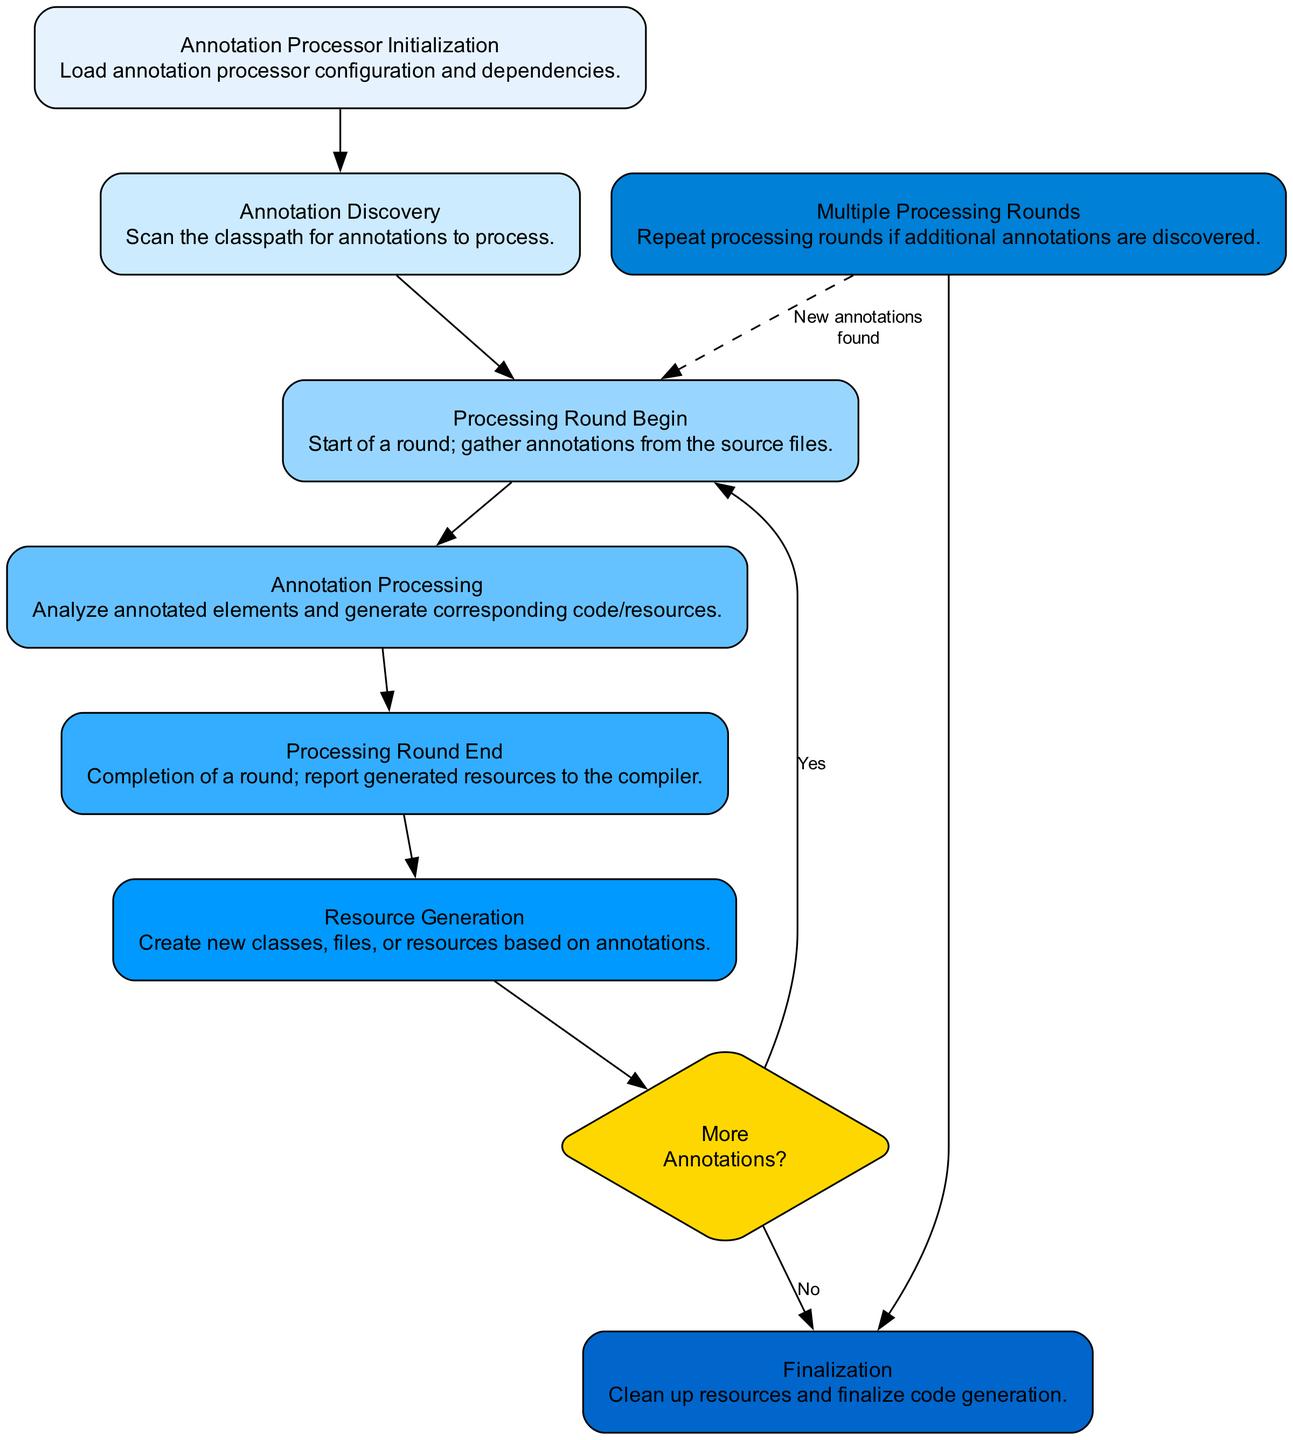What is the first step in the lifecycle? The first step listed in the diagram is "Annotation Processor Initialization," which begins the lifecycle.
Answer: Annotation Processor Initialization How many processing nodes are there in the diagram? There are a total of eight processing nodes, each representing a distinct part of the lifecycle of the Java Annotation Processor.
Answer: 8 What action occurs at the "Processing Round End"? At the "Processing Round End," the action taken is to report generated resources to the compiler, indicating the completion of that round.
Answer: Report generated resources to the compiler What happens when "More Annotations?" is answered with "Yes"? If "More Annotations?" is answered with "Yes," the diagram indicates that the flow returns to "Processing Round Begin" to start another processing round.
Answer: Return to Processing Round Begin Which step follows "Annotation Discovery"? After "Annotation Discovery," the next step is "Processing Round Begin," indicating the start of a processing round to gather annotations.
Answer: Processing Round Begin What does the "Decision" node represent in this diagram? The "Decision" node represents a critical point where the flow decides whether to conduct more processing rounds based on the presence of additional annotations.
Answer: More Annotations? During which phase is "Resource Generation" accomplished? "Resource Generation" is accomplished during the "Annotation Processing" phase, where corresponding code or resources are generated from the analyzed annotations.
Answer: Annotation Processing What condition leads to the "Multiple Processing Rounds" node? The "Multiple Processing Rounds" node is reached when additional annotations are discovered during the processing, necessitating further rounds.
Answer: Additional annotations discovered What is the final step in the process? The final step in the process is "Finalization," which entails cleaning up resources and finalizing the code generation to complete the lifecycle.
Answer: Finalization 